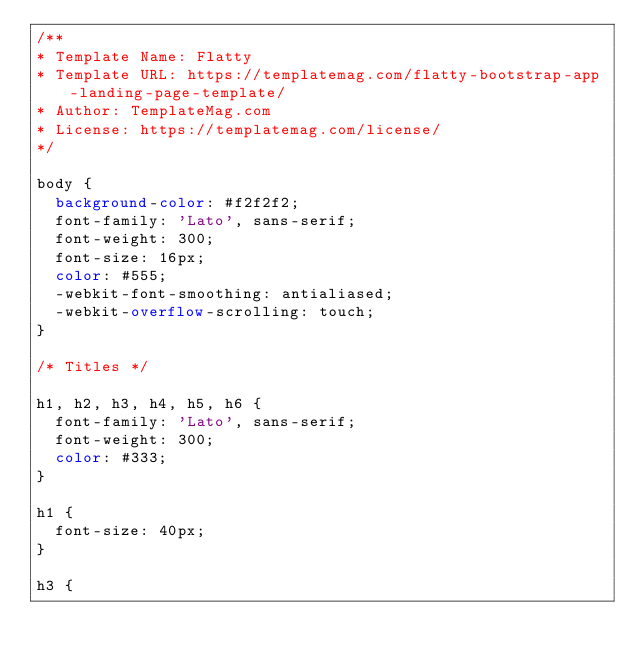<code> <loc_0><loc_0><loc_500><loc_500><_CSS_>/**
* Template Name: Flatty
* Template URL: https://templatemag.com/flatty-bootstrap-app-landing-page-template/
* Author: TemplateMag.com
* License: https://templatemag.com/license/
*/

body {
  background-color: #f2f2f2;
  font-family: 'Lato', sans-serif;
  font-weight: 300;
  font-size: 16px;
  color: #555;
  -webkit-font-smoothing: antialiased;
  -webkit-overflow-scrolling: touch;
}

/* Titles */

h1, h2, h3, h4, h5, h6 {
  font-family: 'Lato', sans-serif;
  font-weight: 300;
  color: #333;
}

h1 {
  font-size: 40px;
}

h3 {</code> 